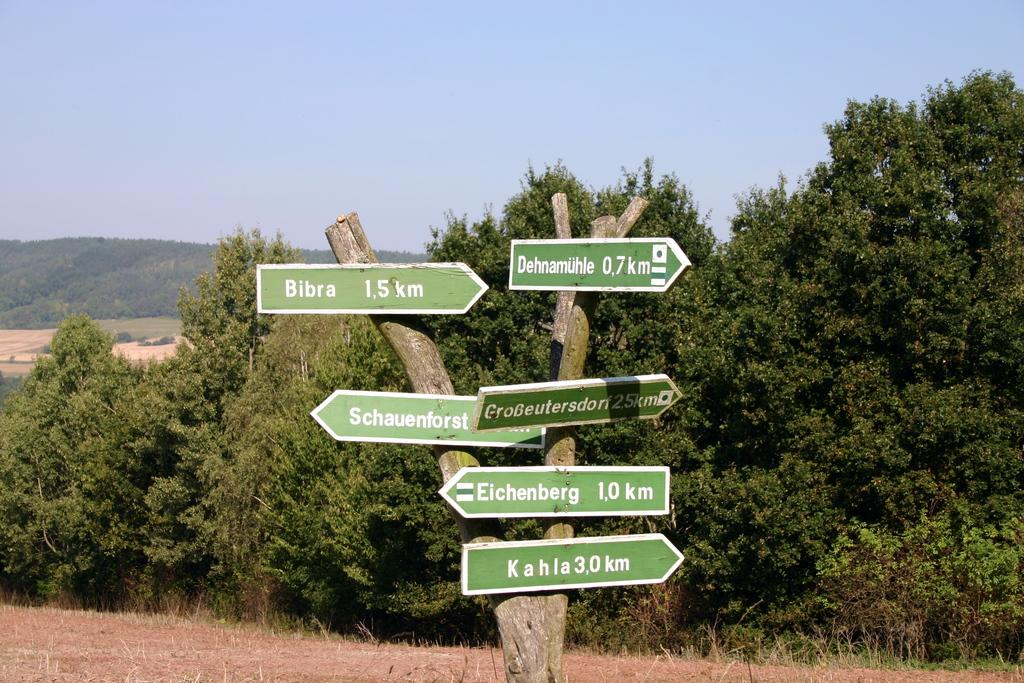Provide a one-sentence caption for the provided image. According to the sign, Bibra is to the right 1.5 km away. 